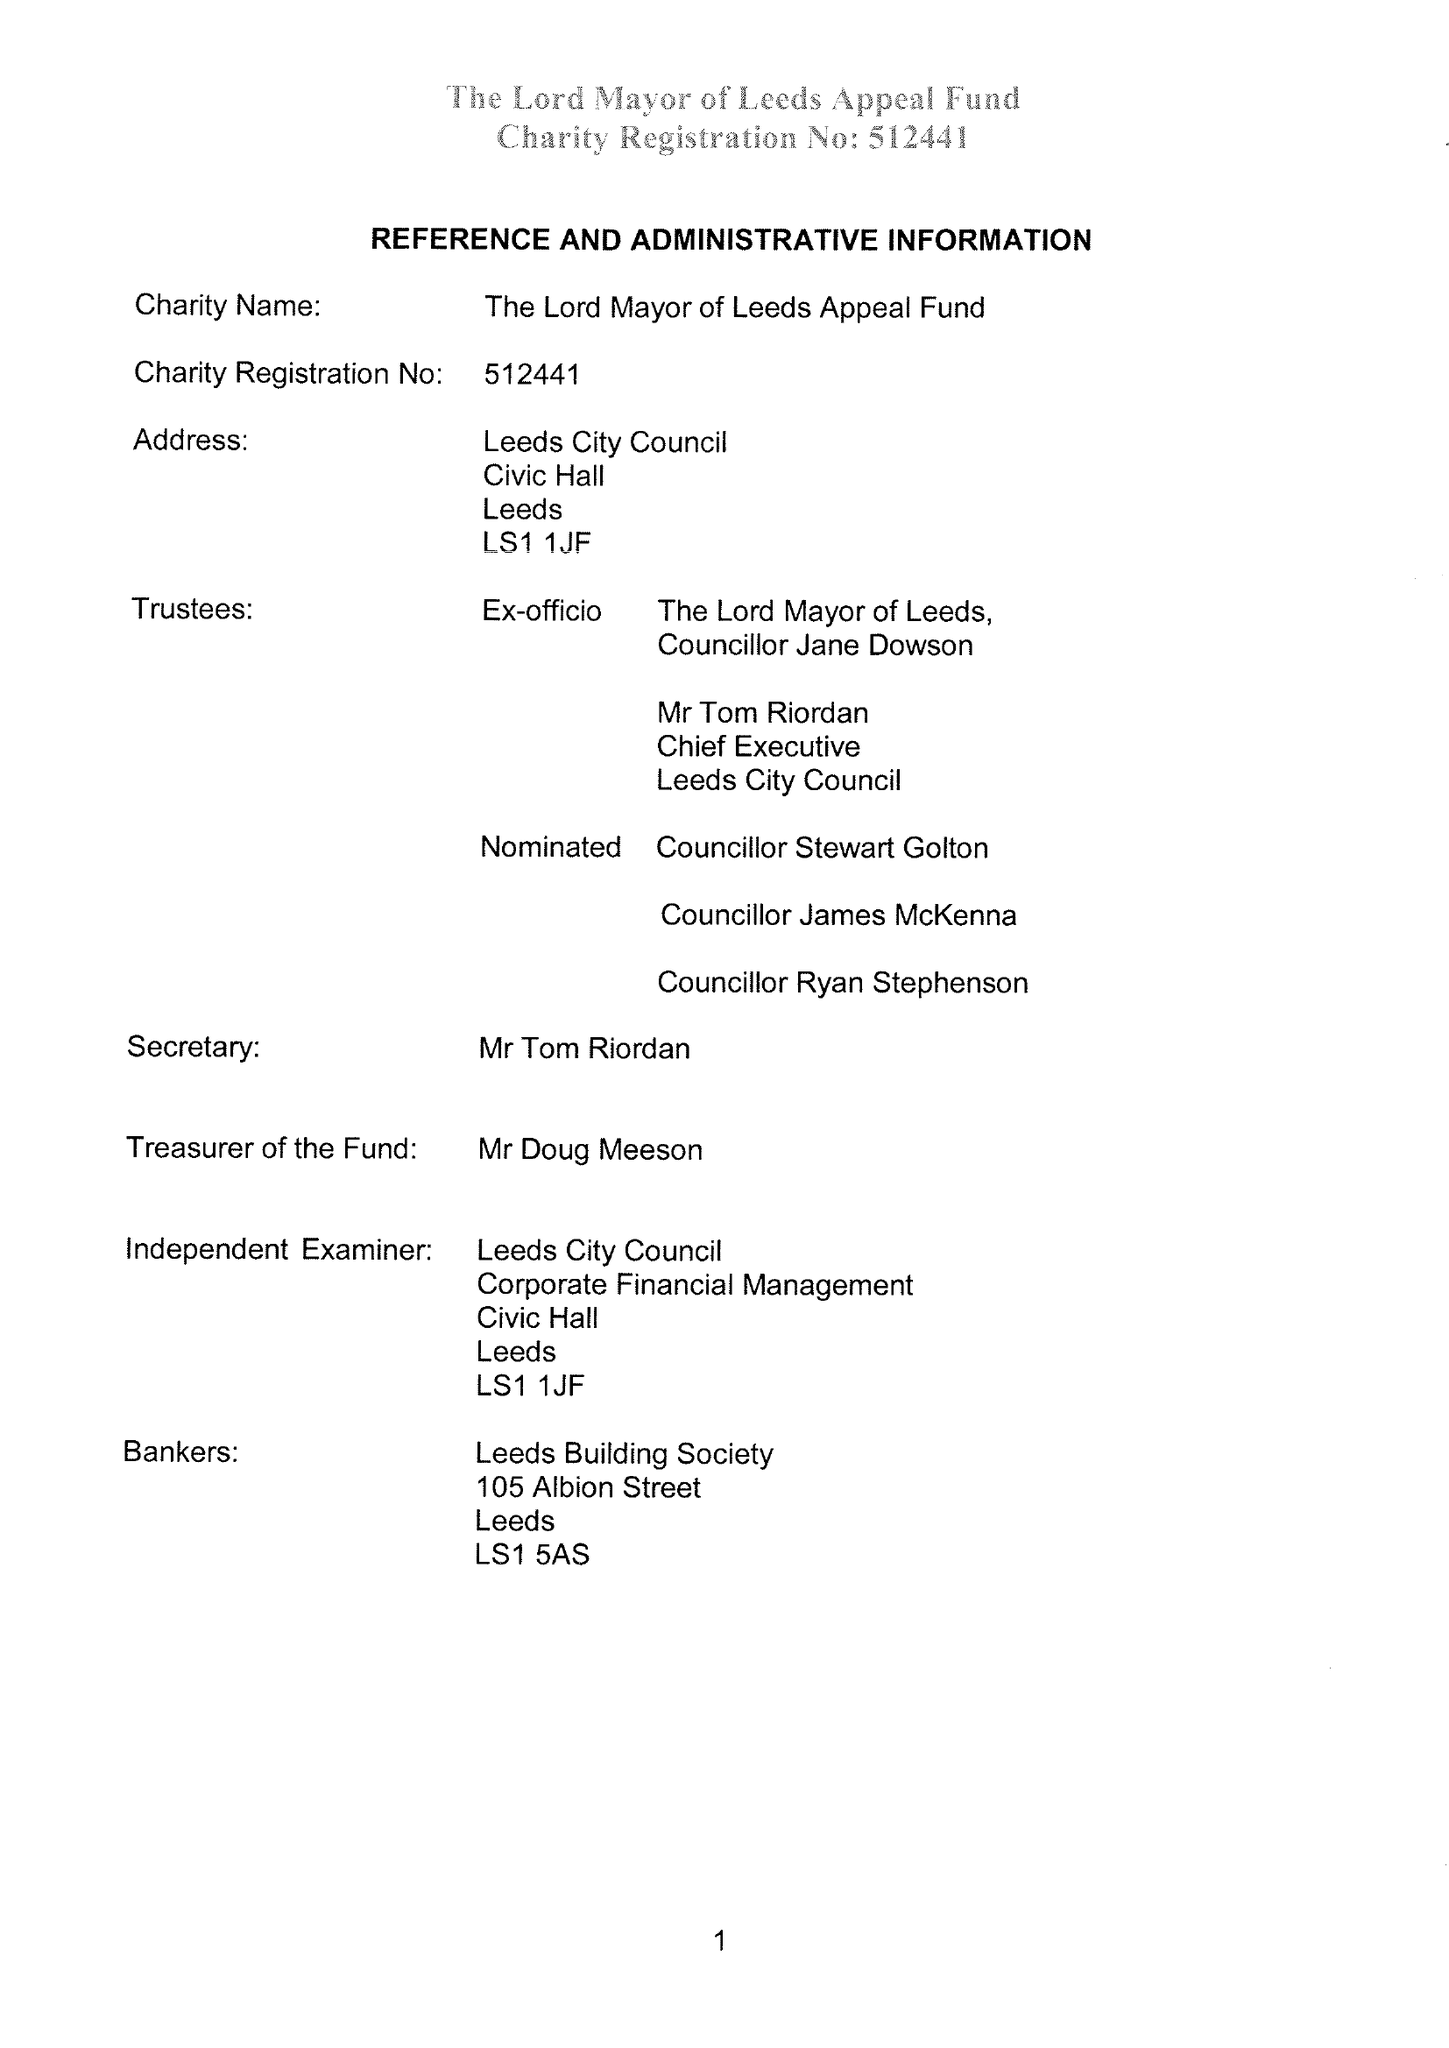What is the value for the address__post_town?
Answer the question using a single word or phrase. LEEDS 